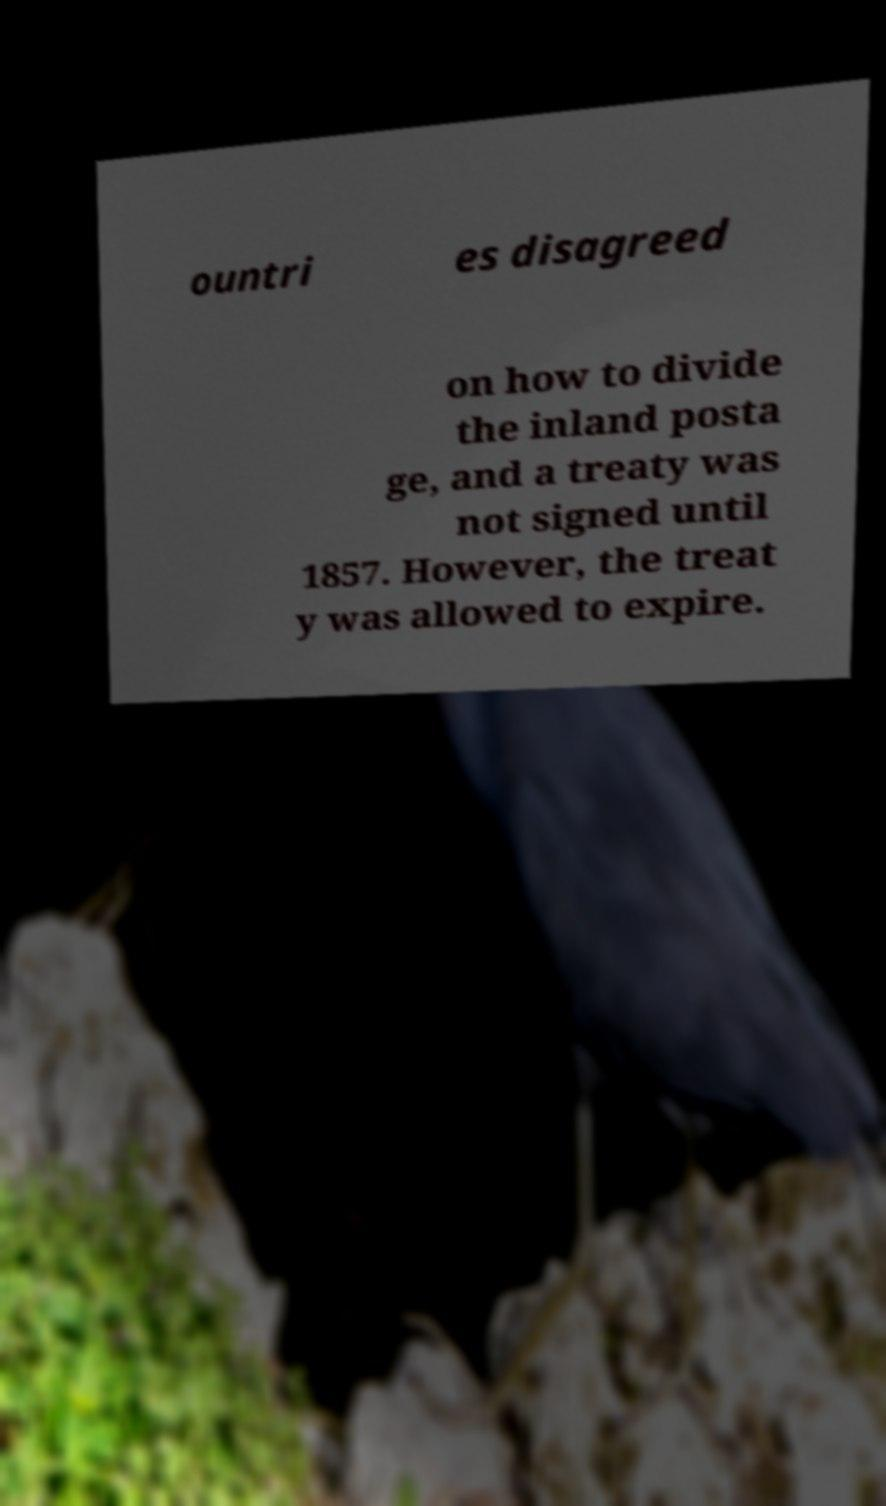What messages or text are displayed in this image? I need them in a readable, typed format. ountri es disagreed on how to divide the inland posta ge, and a treaty was not signed until 1857. However, the treat y was allowed to expire. 